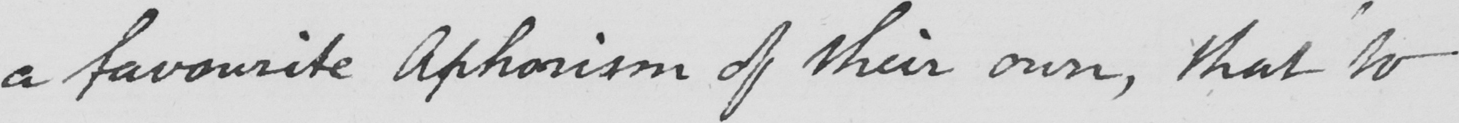Please transcribe the handwritten text in this image. a favourite Aphorism of their own , that to 